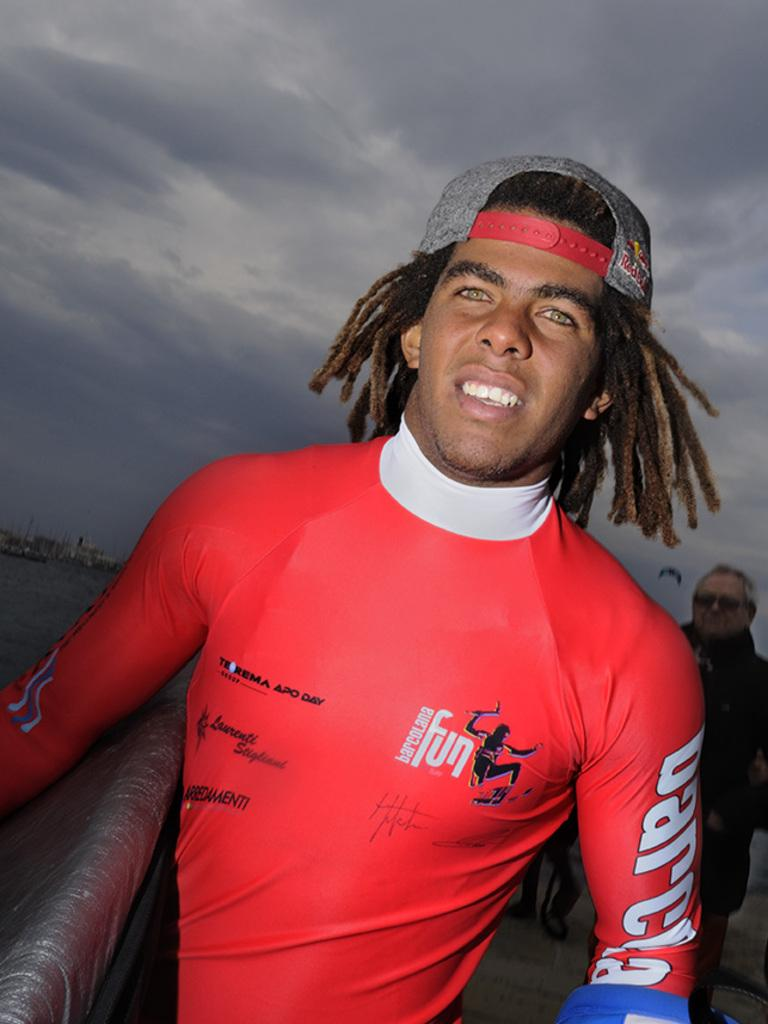<image>
Present a compact description of the photo's key features. Man wearing a red sweater that says "Fun" on the side. 